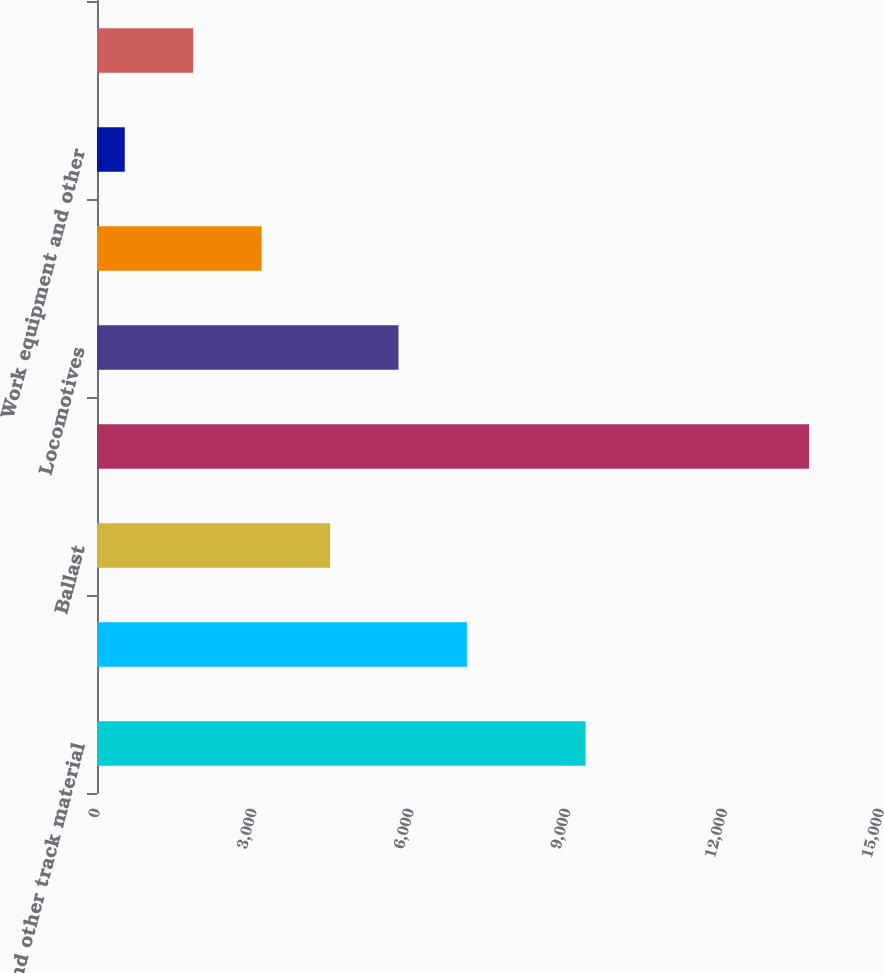Convert chart to OTSL. <chart><loc_0><loc_0><loc_500><loc_500><bar_chart><fcel>Rail and other track material<fcel>Ties<fcel>Ballast<fcel>Other roadway a<fcel>Locomotives<fcel>Freight cars<fcel>Work equipment and other<fcel>Technology and other<nl><fcel>9347<fcel>7077.5<fcel>4458.9<fcel>13624<fcel>5768.2<fcel>3149.6<fcel>531<fcel>1840.3<nl></chart> 